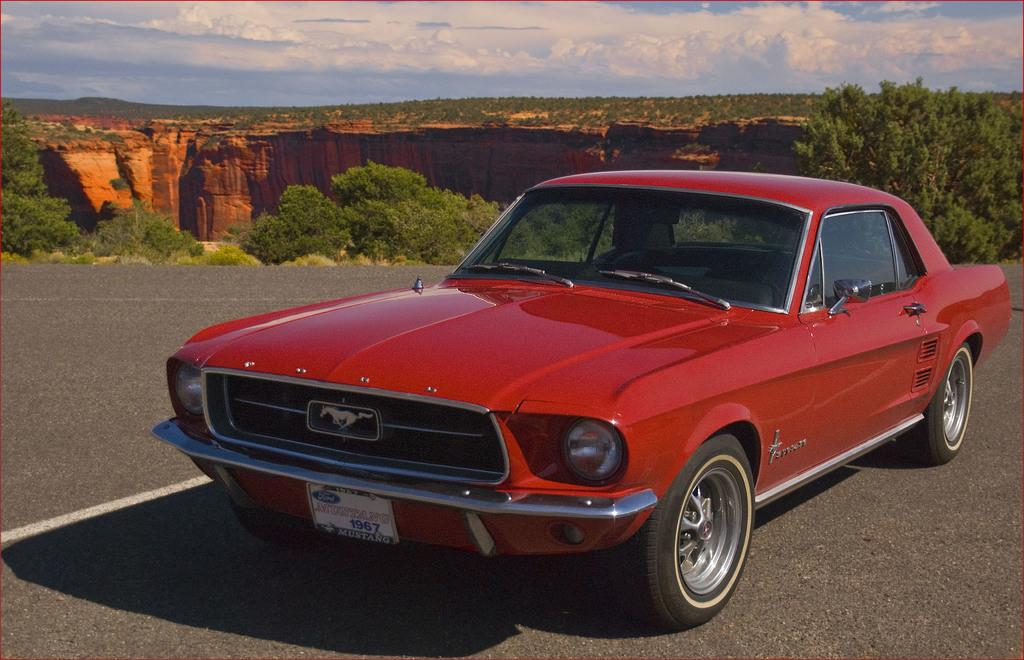What is parked in the image? There is a car parked in the image. What type of natural elements can be seen in the image? Trees are visible in the image. How would you describe the sky in the image? The sky is blue and cloudy in the image. What type of furniture is on fire in the image? There is no furniture or fire present in the image. 